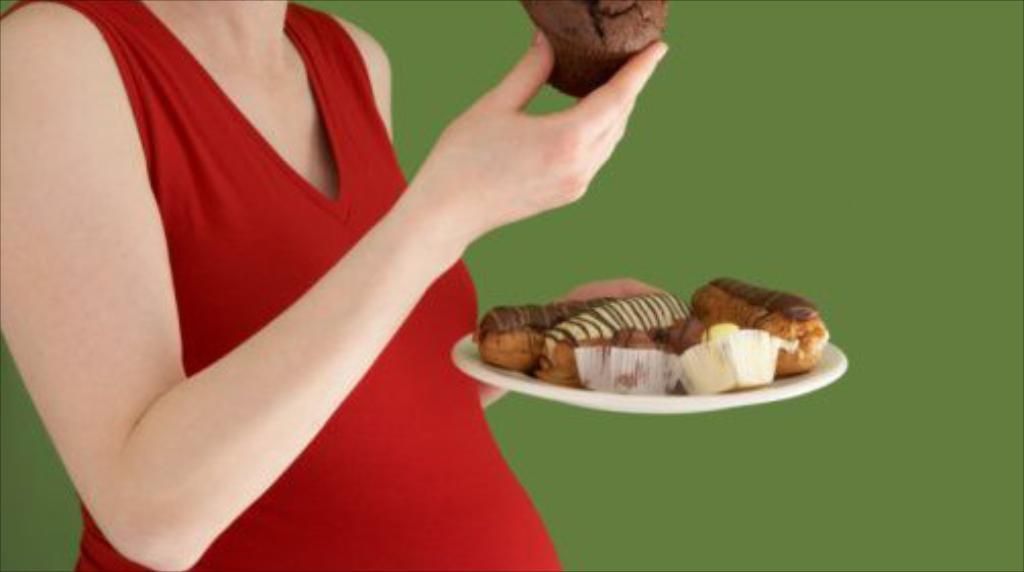Please provide a concise description of this image. There is a lady wearing a red dress. She is holding a plate with cupcakes and some other cakes. In the background there is a green wall. 